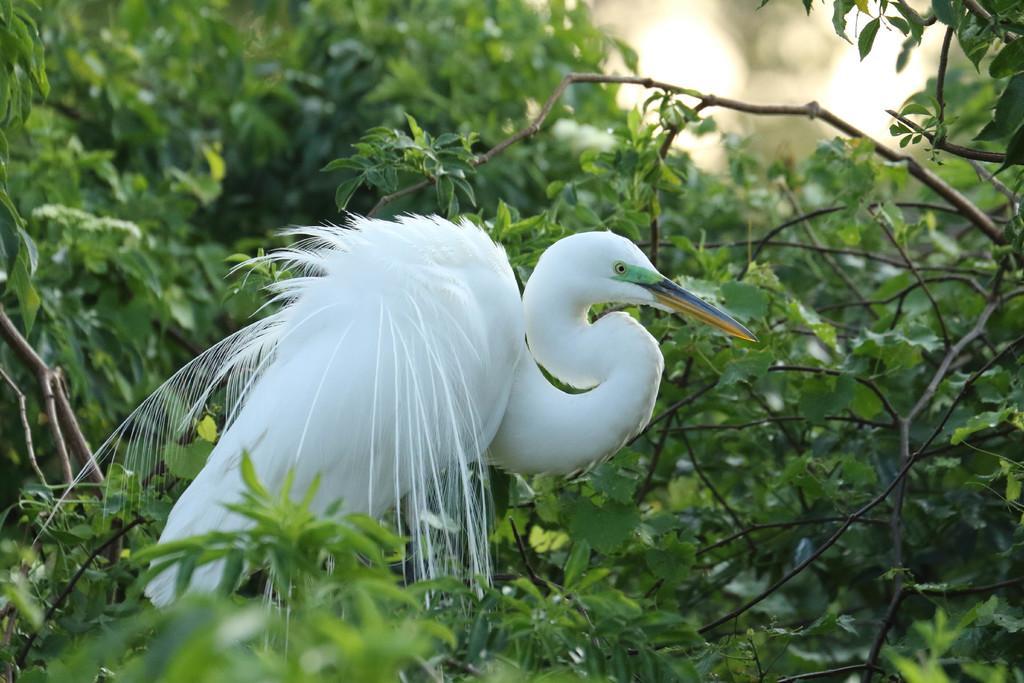How would you summarize this image in a sentence or two? In this picture there is a white color bird with long beak standing on the branch of the tree. At the back there are trees. 